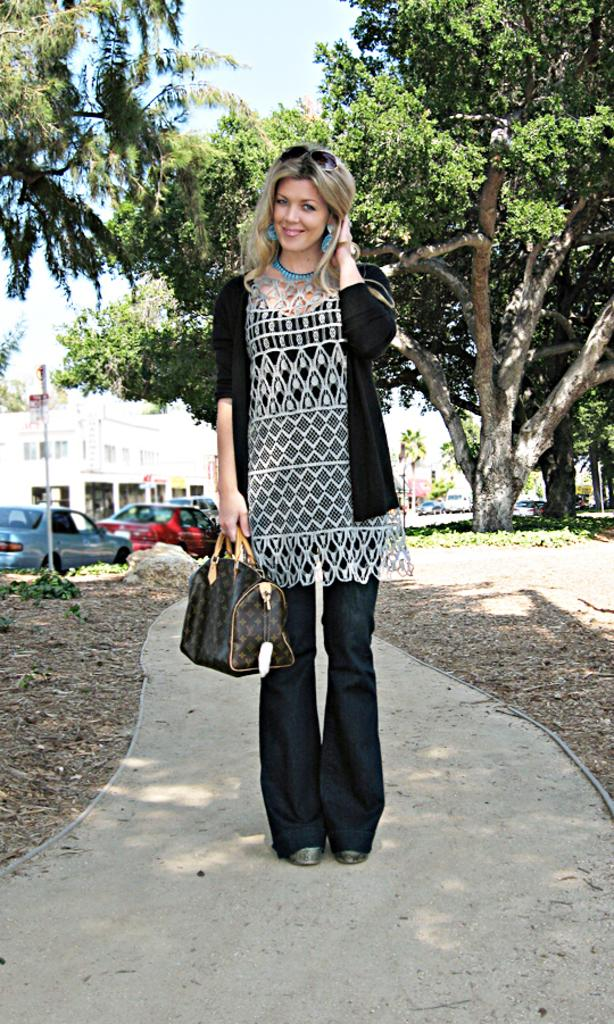Who is the main subject in the image? There is a lady in the center of the image. What is the lady holding in her hand? The lady is holding a bag in her hand. What can be seen on the left side of the image? There are cars on the left side of the image. What type of natural elements are present in the image? There are trees around the image. What type of crib is visible in the image? There is no crib present in the image. Is the lady in the image a farmer? The image does not provide any information about the lady's occupation, so it cannot be determined if she is a farmer. 